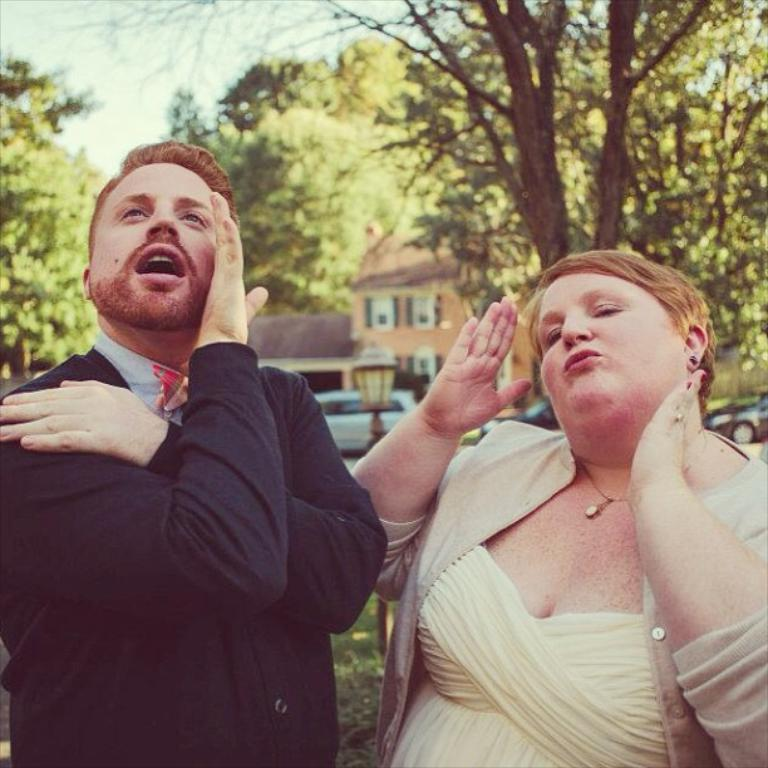How many people are present in the image? There is a lady and a guy in the image. What can be seen in the background of the image? There is a house, a lamp, cars, trees, and plants in the background of the image. Can you describe the setting of the image? The image appears to be set outdoors, given the presence of a house, trees, and plants in the background. What type of produce is being harvested in the image? There is no produce visible in the image; it features a lady, a guy, and various background elements. 